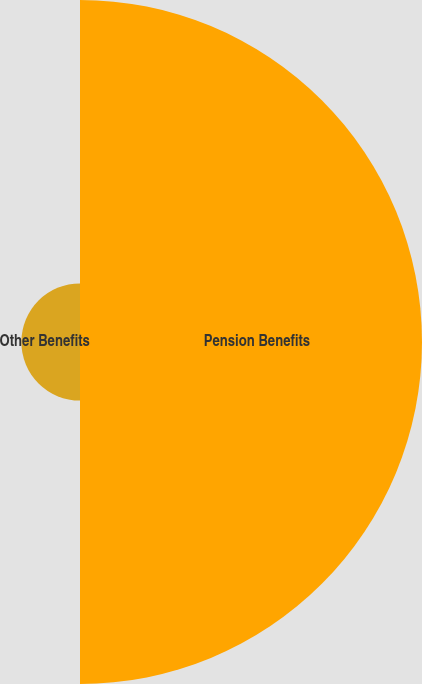<chart> <loc_0><loc_0><loc_500><loc_500><pie_chart><fcel>Pension Benefits<fcel>Other Benefits<nl><fcel>85.37%<fcel>14.63%<nl></chart> 